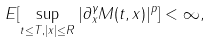Convert formula to latex. <formula><loc_0><loc_0><loc_500><loc_500>E [ \sup _ { t \leq T , | x | \leq R } | \partial _ { x } ^ { \gamma } M ( t , x ) | ^ { p } ] < \infty ,</formula> 